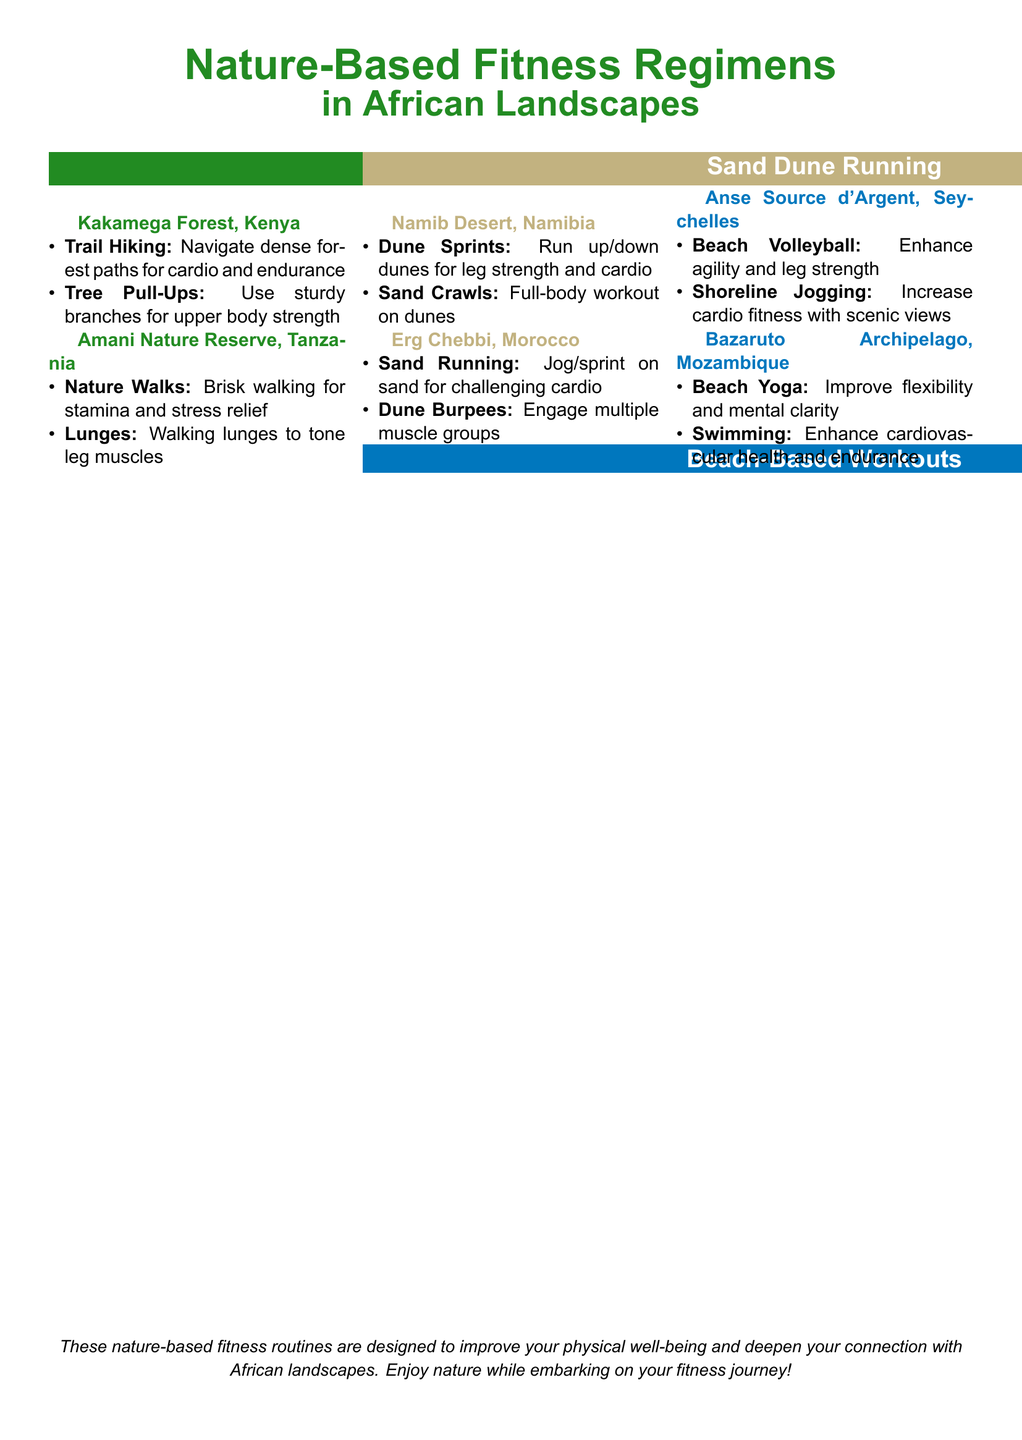What is the first nature-based fitness activity listed for Kakamega Forest? The first activity mentioned is "Trail Hiking" which focuses on navigating dense forest paths for cardio and endurance.
Answer: Trail Hiking How many nature-based workouts are listed for Amani Nature Reserve? There are two workouts given for Amani Nature Reserve which are "Nature Walks" and "Lunges."
Answer: 2 What type of workout is recommended at Anse Source d'Argent? "Beach Volleyball" is one of the recommended workouts which enhances agility and leg strength.
Answer: Beach Volleyball Which desert is mentioned for sand dune running? The document mentions the "Namib Desert" for sand dune running activities.
Answer: Namib Desert What is a benefit of "Beach Yoga" listed for Bazaruto Archipelago? "Beach Yoga" is noted to improve flexibility and mental clarity.
Answer: Flexibility and mental clarity How many different locations are suggested for beach-based workouts? There are two locations noted for beach-based workouts: Anse Source d'Argent and Bazaruto Archipelago.
Answer: 2 What are "Dune Sprints" primarily used for? "Dune Sprints" are designed to build leg strength and improve cardio.
Answer: Leg strength and cardio What location is associated with "Sand Crawls"? "Sand Crawls" is associated with the Namib Desert.
Answer: Namib Desert 